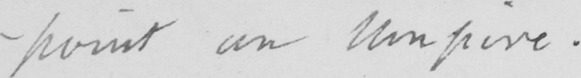Please transcribe the handwritten text in this image. -point an umpire . 